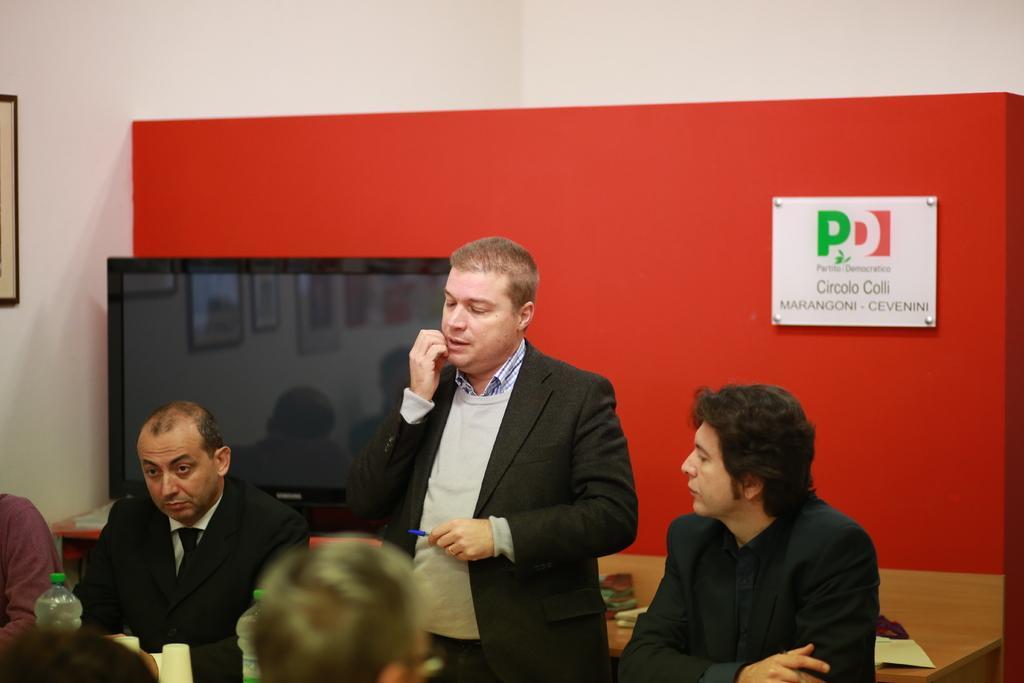Describe this image in one or two sentences. In the middle of the image a man is standing and holding a pen. Bottom left side of the image few people are sitting. At the top of the image there is a wall, On the wall there is a frame. In the middle of the image there is a screen. 